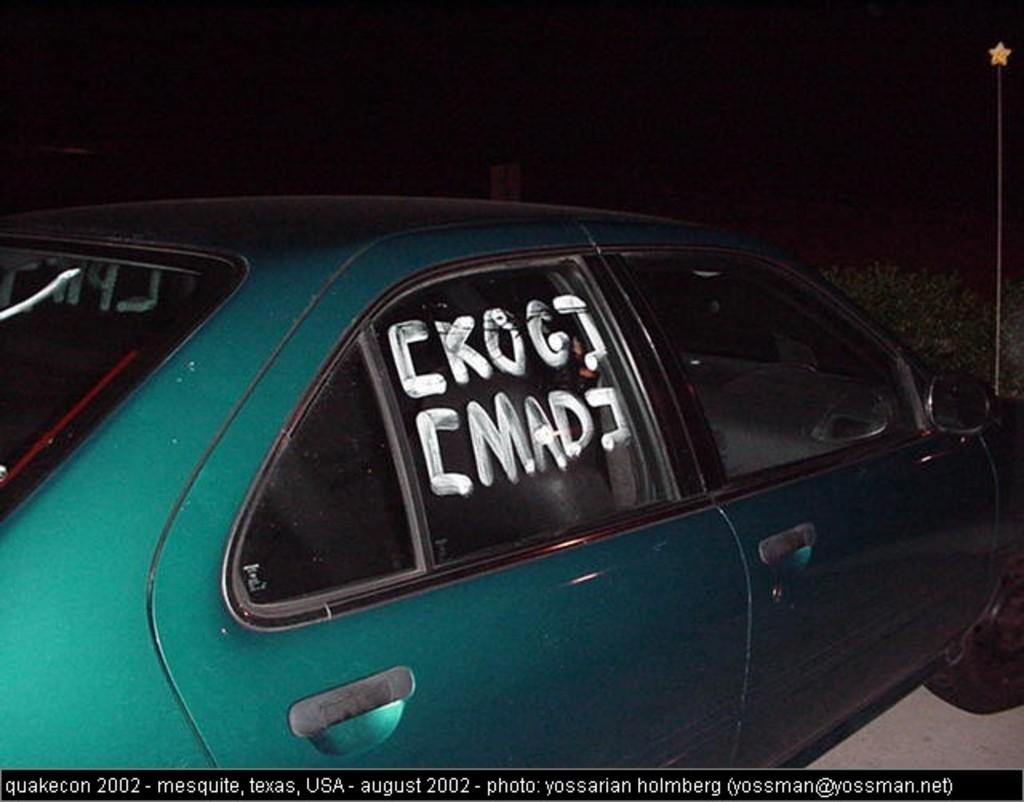What is the main subject in the image? There is a vehicle in the image. What else can be seen in the image besides the vehicle? There are plants and a pole visible in the image. What is the color of the sky in the image? The sky is dark in the image. What is visible at the bottom of the image? There is some text at the bottom of the image. What type of thread is being used to hang the poisonous cherries in the image? There are no cherries, poisonous or otherwise, nor any thread present in the image. 